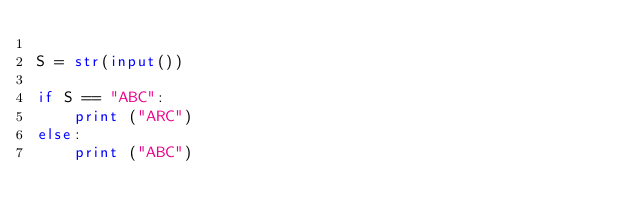Convert code to text. <code><loc_0><loc_0><loc_500><loc_500><_Python_>
S = str(input())

if S == "ABC":
    print ("ARC")
else:
    print ("ABC")</code> 